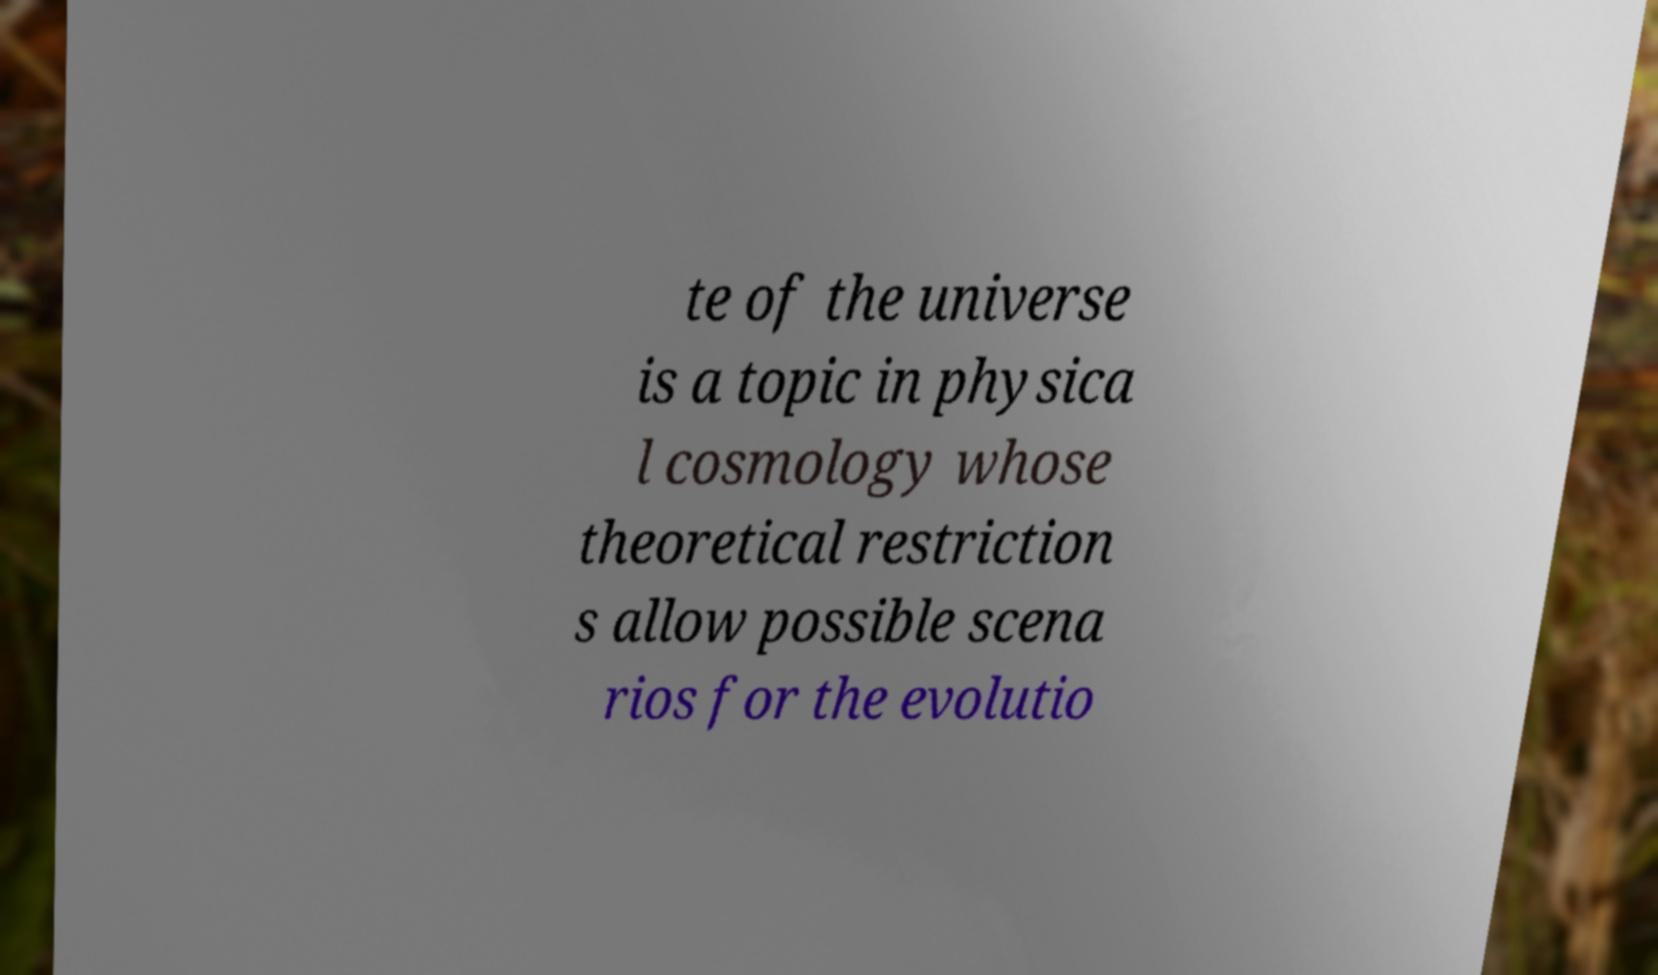There's text embedded in this image that I need extracted. Can you transcribe it verbatim? te of the universe is a topic in physica l cosmology whose theoretical restriction s allow possible scena rios for the evolutio 